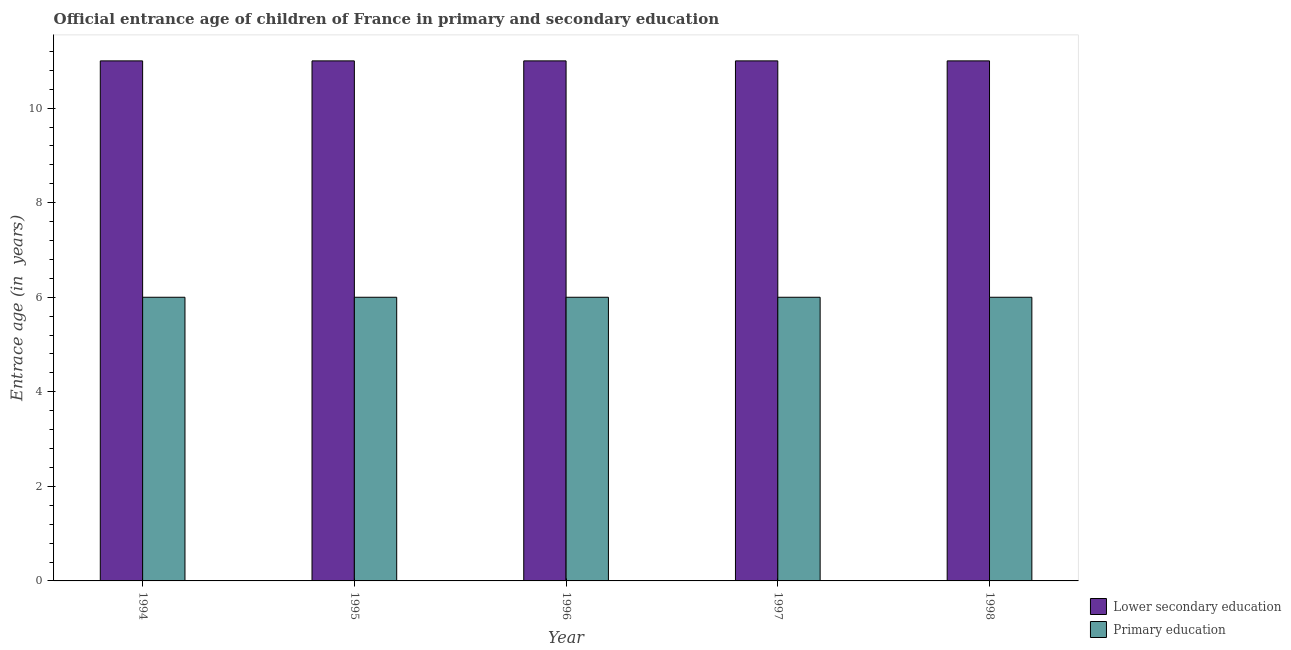How many groups of bars are there?
Provide a short and direct response. 5. How many bars are there on the 5th tick from the left?
Provide a succinct answer. 2. How many bars are there on the 5th tick from the right?
Make the answer very short. 2. In how many cases, is the number of bars for a given year not equal to the number of legend labels?
Provide a succinct answer. 0. What is the entrance age of children in lower secondary education in 1996?
Offer a terse response. 11. Across all years, what is the maximum entrance age of children in lower secondary education?
Offer a very short reply. 11. Across all years, what is the minimum entrance age of chiildren in primary education?
Offer a terse response. 6. In which year was the entrance age of children in lower secondary education maximum?
Provide a short and direct response. 1994. In which year was the entrance age of children in lower secondary education minimum?
Offer a very short reply. 1994. What is the total entrance age of children in lower secondary education in the graph?
Offer a terse response. 55. What is the difference between the entrance age of children in lower secondary education in 1997 and that in 1998?
Your response must be concise. 0. What is the difference between the entrance age of children in lower secondary education in 1997 and the entrance age of chiildren in primary education in 1995?
Give a very brief answer. 0. What is the average entrance age of children in lower secondary education per year?
Offer a terse response. 11. In the year 1995, what is the difference between the entrance age of chiildren in primary education and entrance age of children in lower secondary education?
Provide a succinct answer. 0. What is the difference between the highest and the lowest entrance age of chiildren in primary education?
Provide a short and direct response. 0. What does the 2nd bar from the right in 1995 represents?
Make the answer very short. Lower secondary education. How many bars are there?
Your answer should be compact. 10. Are all the bars in the graph horizontal?
Provide a short and direct response. No. What is the difference between two consecutive major ticks on the Y-axis?
Offer a very short reply. 2. Does the graph contain grids?
Ensure brevity in your answer.  No. Where does the legend appear in the graph?
Your answer should be compact. Bottom right. How many legend labels are there?
Your response must be concise. 2. What is the title of the graph?
Make the answer very short. Official entrance age of children of France in primary and secondary education. What is the label or title of the Y-axis?
Offer a very short reply. Entrace age (in  years). What is the Entrace age (in  years) of Primary education in 1994?
Your answer should be very brief. 6. What is the Entrace age (in  years) in Lower secondary education in 1995?
Offer a terse response. 11. What is the Entrace age (in  years) of Primary education in 1996?
Ensure brevity in your answer.  6. What is the Entrace age (in  years) of Primary education in 1998?
Provide a succinct answer. 6. Across all years, what is the maximum Entrace age (in  years) in Lower secondary education?
Provide a succinct answer. 11. Across all years, what is the maximum Entrace age (in  years) of Primary education?
Provide a short and direct response. 6. Across all years, what is the minimum Entrace age (in  years) of Primary education?
Your answer should be very brief. 6. What is the total Entrace age (in  years) in Lower secondary education in the graph?
Ensure brevity in your answer.  55. What is the difference between the Entrace age (in  years) of Lower secondary education in 1994 and that in 1995?
Provide a succinct answer. 0. What is the difference between the Entrace age (in  years) of Primary education in 1994 and that in 1996?
Offer a very short reply. 0. What is the difference between the Entrace age (in  years) in Primary education in 1994 and that in 1998?
Your response must be concise. 0. What is the difference between the Entrace age (in  years) of Lower secondary education in 1995 and that in 1996?
Make the answer very short. 0. What is the difference between the Entrace age (in  years) of Primary education in 1995 and that in 1996?
Offer a very short reply. 0. What is the difference between the Entrace age (in  years) of Lower secondary education in 1995 and that in 1997?
Keep it short and to the point. 0. What is the difference between the Entrace age (in  years) in Lower secondary education in 1995 and that in 1998?
Provide a short and direct response. 0. What is the difference between the Entrace age (in  years) in Primary education in 1995 and that in 1998?
Keep it short and to the point. 0. What is the difference between the Entrace age (in  years) of Lower secondary education in 1996 and that in 1997?
Your answer should be very brief. 0. What is the difference between the Entrace age (in  years) of Primary education in 1997 and that in 1998?
Offer a terse response. 0. What is the difference between the Entrace age (in  years) of Lower secondary education in 1994 and the Entrace age (in  years) of Primary education in 1996?
Provide a short and direct response. 5. What is the difference between the Entrace age (in  years) of Lower secondary education in 1994 and the Entrace age (in  years) of Primary education in 1997?
Ensure brevity in your answer.  5. What is the difference between the Entrace age (in  years) of Lower secondary education in 1994 and the Entrace age (in  years) of Primary education in 1998?
Your response must be concise. 5. What is the difference between the Entrace age (in  years) of Lower secondary education in 1995 and the Entrace age (in  years) of Primary education in 1997?
Offer a very short reply. 5. What is the difference between the Entrace age (in  years) in Lower secondary education in 1996 and the Entrace age (in  years) in Primary education in 1997?
Your response must be concise. 5. What is the difference between the Entrace age (in  years) in Lower secondary education in 1996 and the Entrace age (in  years) in Primary education in 1998?
Offer a terse response. 5. What is the difference between the Entrace age (in  years) in Lower secondary education in 1997 and the Entrace age (in  years) in Primary education in 1998?
Your answer should be compact. 5. What is the average Entrace age (in  years) of Lower secondary education per year?
Your answer should be very brief. 11. In the year 1995, what is the difference between the Entrace age (in  years) of Lower secondary education and Entrace age (in  years) of Primary education?
Ensure brevity in your answer.  5. In the year 1996, what is the difference between the Entrace age (in  years) of Lower secondary education and Entrace age (in  years) of Primary education?
Give a very brief answer. 5. In the year 1997, what is the difference between the Entrace age (in  years) of Lower secondary education and Entrace age (in  years) of Primary education?
Make the answer very short. 5. What is the ratio of the Entrace age (in  years) in Lower secondary education in 1994 to that in 1995?
Your answer should be compact. 1. What is the ratio of the Entrace age (in  years) of Primary education in 1994 to that in 1995?
Your answer should be very brief. 1. What is the ratio of the Entrace age (in  years) in Lower secondary education in 1994 to that in 1996?
Make the answer very short. 1. What is the ratio of the Entrace age (in  years) in Lower secondary education in 1994 to that in 1997?
Offer a very short reply. 1. What is the ratio of the Entrace age (in  years) of Lower secondary education in 1994 to that in 1998?
Ensure brevity in your answer.  1. What is the ratio of the Entrace age (in  years) in Lower secondary education in 1995 to that in 1996?
Your response must be concise. 1. What is the ratio of the Entrace age (in  years) of Primary education in 1995 to that in 1996?
Keep it short and to the point. 1. What is the ratio of the Entrace age (in  years) of Primary education in 1995 to that in 1997?
Provide a short and direct response. 1. What is the ratio of the Entrace age (in  years) in Primary education in 1995 to that in 1998?
Provide a short and direct response. 1. What is the ratio of the Entrace age (in  years) of Lower secondary education in 1996 to that in 1997?
Your response must be concise. 1. What is the ratio of the Entrace age (in  years) of Primary education in 1996 to that in 1997?
Your response must be concise. 1. What is the ratio of the Entrace age (in  years) in Lower secondary education in 1996 to that in 1998?
Give a very brief answer. 1. What is the ratio of the Entrace age (in  years) in Primary education in 1996 to that in 1998?
Provide a succinct answer. 1. What is the ratio of the Entrace age (in  years) of Lower secondary education in 1997 to that in 1998?
Ensure brevity in your answer.  1. What is the difference between the highest and the second highest Entrace age (in  years) in Primary education?
Your answer should be compact. 0. What is the difference between the highest and the lowest Entrace age (in  years) of Lower secondary education?
Your answer should be compact. 0. 